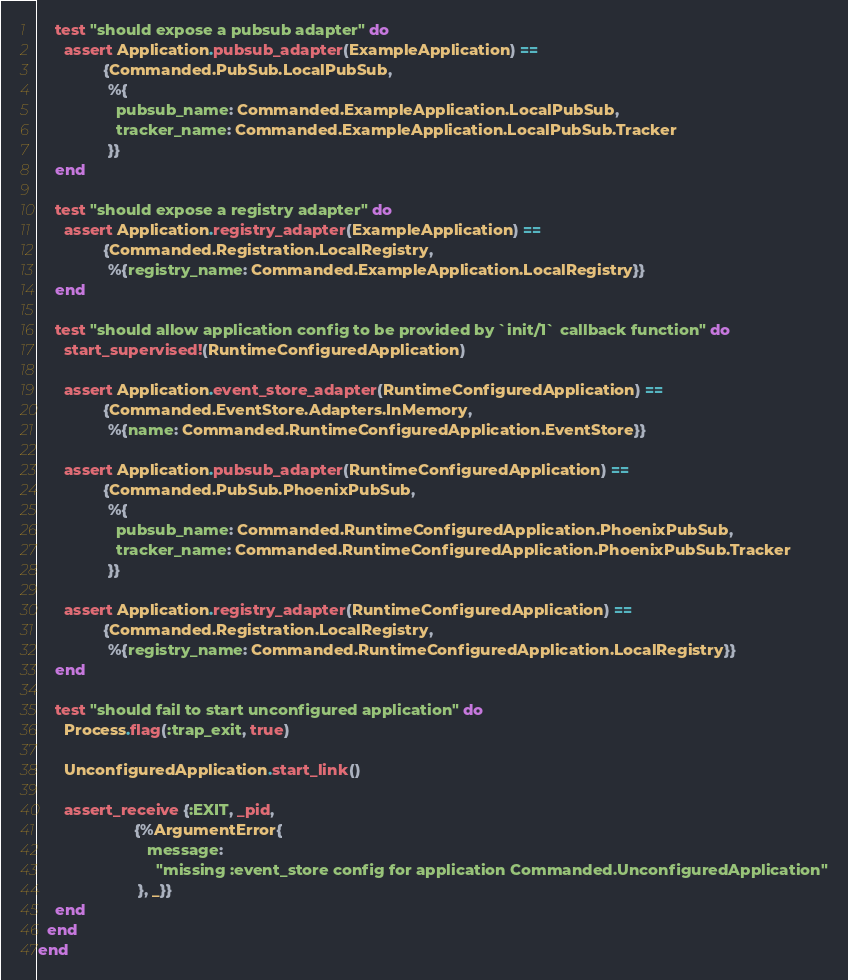Convert code to text. <code><loc_0><loc_0><loc_500><loc_500><_Elixir_>    test "should expose a pubsub adapter" do
      assert Application.pubsub_adapter(ExampleApplication) ==
               {Commanded.PubSub.LocalPubSub,
                %{
                  pubsub_name: Commanded.ExampleApplication.LocalPubSub,
                  tracker_name: Commanded.ExampleApplication.LocalPubSub.Tracker
                }}
    end

    test "should expose a registry adapter" do
      assert Application.registry_adapter(ExampleApplication) ==
               {Commanded.Registration.LocalRegistry,
                %{registry_name: Commanded.ExampleApplication.LocalRegistry}}
    end

    test "should allow application config to be provided by `init/1` callback function" do
      start_supervised!(RuntimeConfiguredApplication)

      assert Application.event_store_adapter(RuntimeConfiguredApplication) ==
               {Commanded.EventStore.Adapters.InMemory,
                %{name: Commanded.RuntimeConfiguredApplication.EventStore}}

      assert Application.pubsub_adapter(RuntimeConfiguredApplication) ==
               {Commanded.PubSub.PhoenixPubSub,
                %{
                  pubsub_name: Commanded.RuntimeConfiguredApplication.PhoenixPubSub,
                  tracker_name: Commanded.RuntimeConfiguredApplication.PhoenixPubSub.Tracker
                }}

      assert Application.registry_adapter(RuntimeConfiguredApplication) ==
               {Commanded.Registration.LocalRegistry,
                %{registry_name: Commanded.RuntimeConfiguredApplication.LocalRegistry}}
    end

    test "should fail to start unconfigured application" do
      Process.flag(:trap_exit, true)

      UnconfiguredApplication.start_link()

      assert_receive {:EXIT, _pid,
                      {%ArgumentError{
                         message:
                           "missing :event_store config for application Commanded.UnconfiguredApplication"
                       }, _}}
    end
  end
end
</code> 